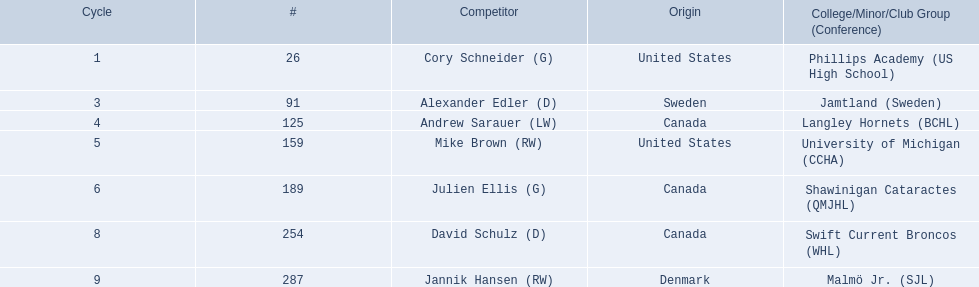Help me parse the entirety of this table. {'header': ['Cycle', '#', 'Competitor', 'Origin', 'College/Minor/Club Group (Conference)'], 'rows': [['1', '26', 'Cory Schneider (G)', 'United States', 'Phillips Academy (US High School)'], ['3', '91', 'Alexander Edler (D)', 'Sweden', 'Jamtland (Sweden)'], ['4', '125', 'Andrew Sarauer (LW)', 'Canada', 'Langley Hornets (BCHL)'], ['5', '159', 'Mike Brown (RW)', 'United States', 'University of Michigan (CCHA)'], ['6', '189', 'Julien Ellis (G)', 'Canada', 'Shawinigan Cataractes (QMJHL)'], ['8', '254', 'David Schulz (D)', 'Canada', 'Swift Current Broncos (WHL)'], ['9', '287', 'Jannik Hansen (RW)', 'Denmark', 'Malmö Jr. (SJL)']]} Who were the players in the 2004-05 vancouver canucks season Cory Schneider (G), Alexander Edler (D), Andrew Sarauer (LW), Mike Brown (RW), Julien Ellis (G), David Schulz (D), Jannik Hansen (RW). Of these players who had a nationality of denmark? Jannik Hansen (RW). 